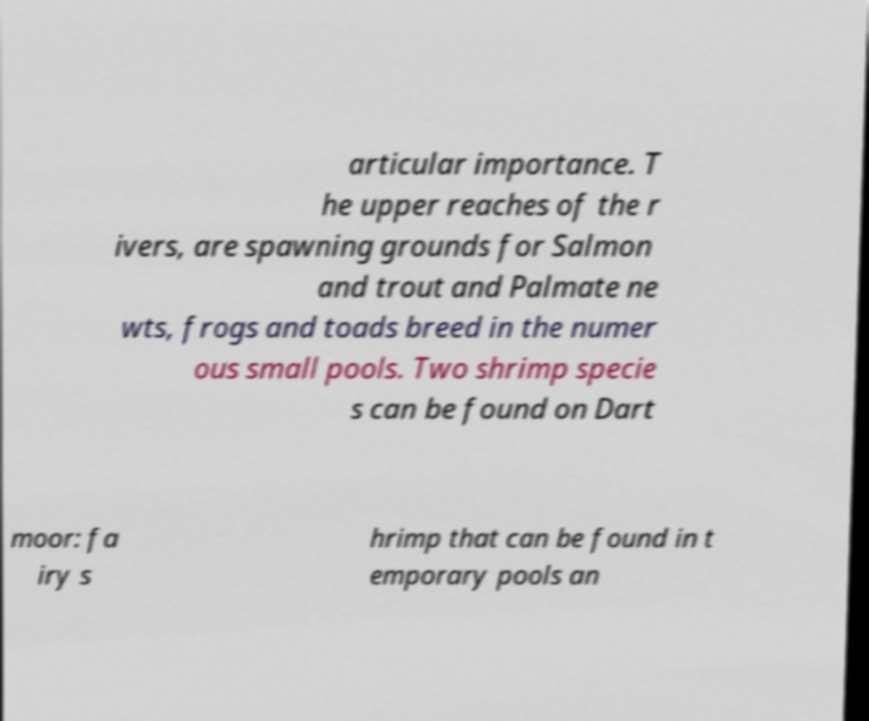For documentation purposes, I need the text within this image transcribed. Could you provide that? articular importance. T he upper reaches of the r ivers, are spawning grounds for Salmon and trout and Palmate ne wts, frogs and toads breed in the numer ous small pools. Two shrimp specie s can be found on Dart moor: fa iry s hrimp that can be found in t emporary pools an 